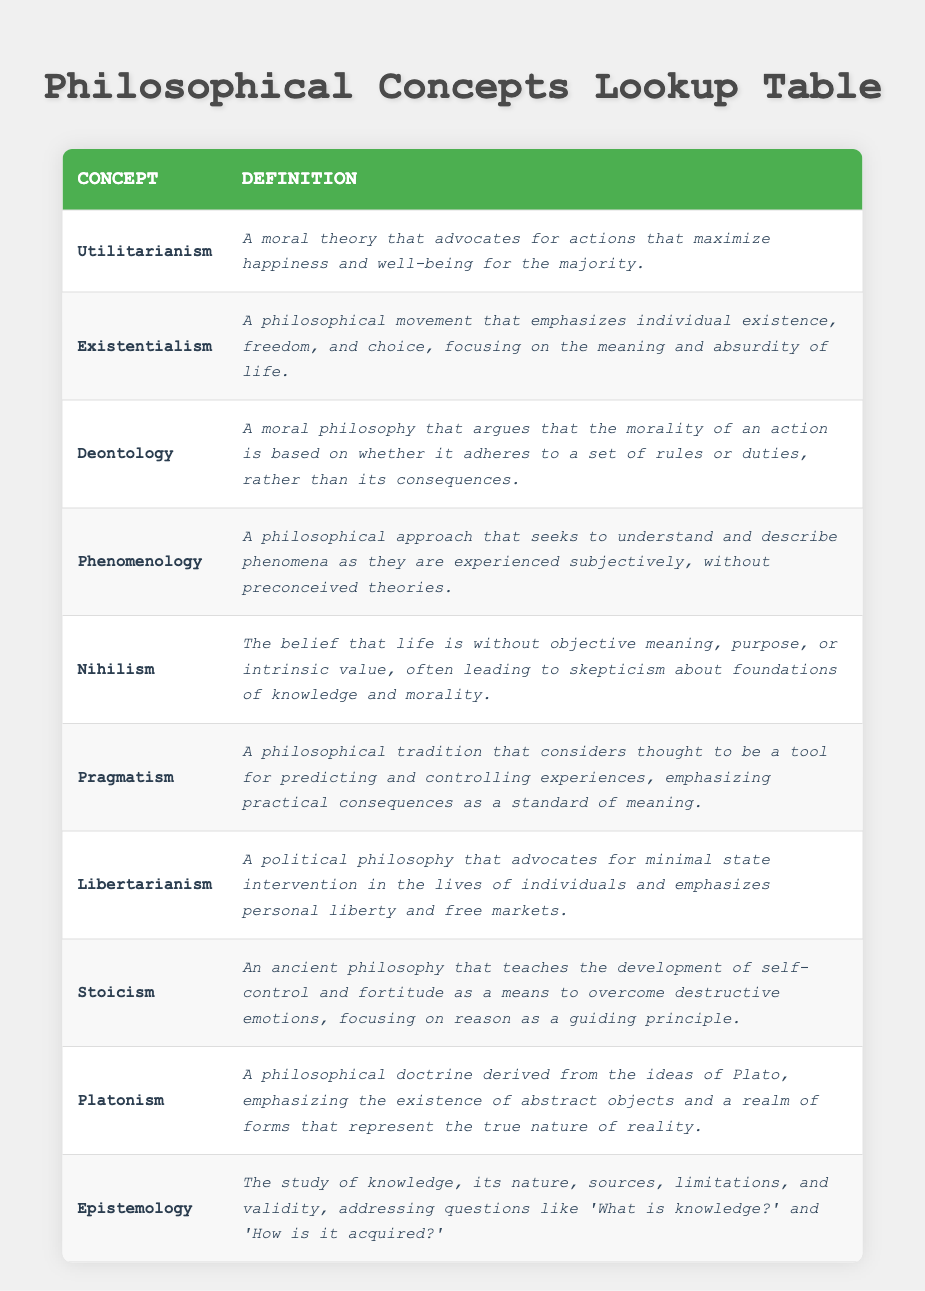What is the definition of Utilitarianism? The definition can be found in the "Definition" column under the "Utilitarianism" entry, which states that it is "A moral theory that advocates for actions that maximize happiness and well-being for the majority."
Answer: A moral theory that advocates for actions that maximize happiness and well-being for the majority Is Existentialism a philosophical movement that focuses on individual existence? The table states that Existentialism is a philosophical movement emphasizing individual existence, freedom, and choice. Therefore, the statement is true based on this information.
Answer: Yes How many concepts listed in the table are associated with ethics or morality? The moral theories present in the table include Utilitarianism, Deontology, and Nihilism. Counting these gives a total of 3 concepts associated with ethics or morality.
Answer: 3 What are the defining characteristics of Stoicism according to the table? Stoicism is defined in the table as an ancient philosophy that teaches the development of self-control and fortitude to overcome destructive emotions, focusing on reason. This indicates its emphasis on emotional resilience and rationality.
Answer: Development of self-control and fortitude; overcoming destructive emotions; focusing on reason If we combine the concepts of Libertarianism and Pragmatism, what common theme do they share? Both concepts focus on individual liberty and practical consequences in their respective fields—Libertarianism in political philosophy and Pragmatism in philosophical tradition. Thus, the common theme relates to personal freedom and practical decision-making.
Answer: Individual liberty and practical consequences 